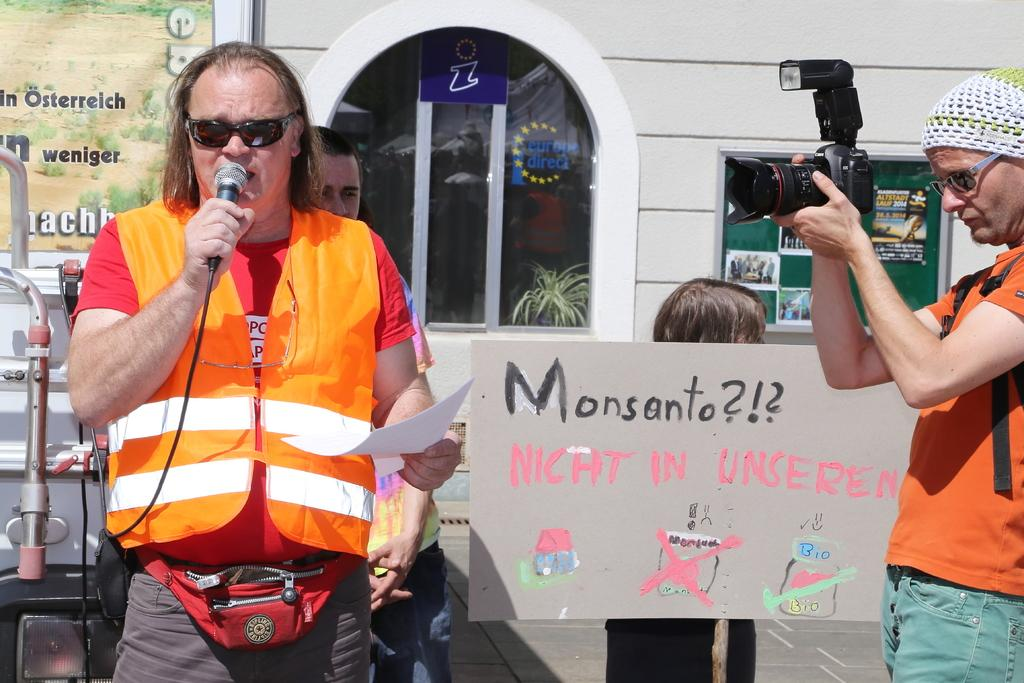What is the man in the image doing? The man is talking on a mic. Are there any other people in the image? Yes, there are two persons behind the man with the mic. What can be seen in the background of the image? There is a banner, a door, and a building in the background. Is there any other banner visible in the image? Yes, there is another banner in the background. What is the man on the left doing? The man on the left is capturing pictures. What type of orange is being served for dinner in the image? There is no orange or dinner present in the image. 